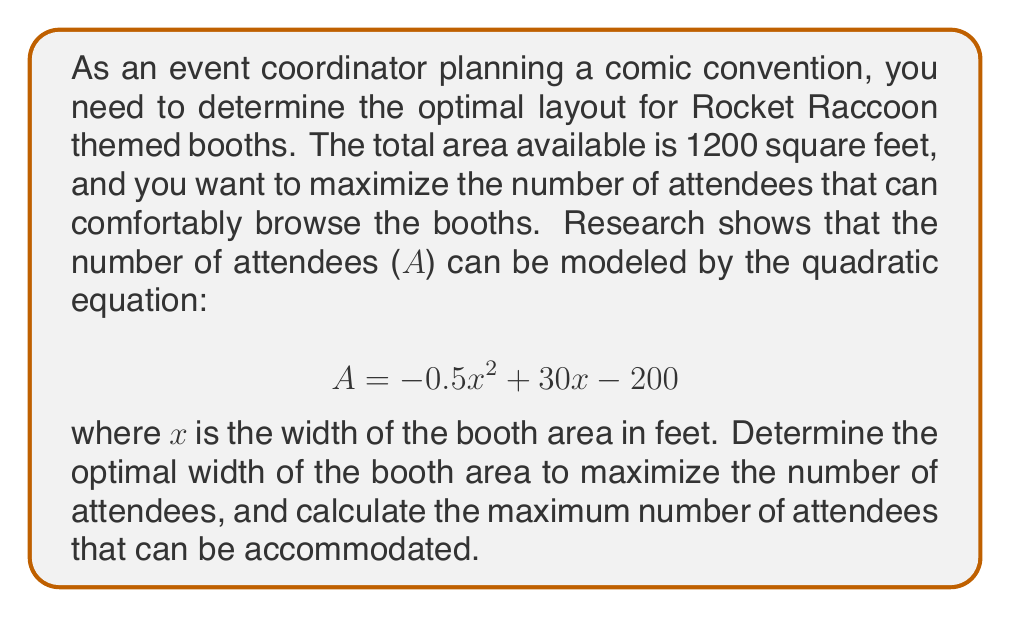Teach me how to tackle this problem. To solve this problem, we'll follow these steps:

1) First, we need to find the vertex of the parabola, which represents the maximum point. We can do this using the vertex formula: $x = -\frac{b}{2a}$

2) In this equation, $a = -0.5$ and $b = 30$. Let's substitute these values:

   $$x = -\frac{30}{2(-0.5)} = -\frac{30}{-1} = 30$$

3) This means the optimal width of the booth area is 30 feet.

4) To find the maximum number of attendees, we substitute x = 30 into the original equation:

   $$A = -0.5(30)^2 + 30(30) - 200$$

5) Let's calculate this step by step:
   $$A = -0.5(900) + 900 - 200$$
   $$A = -450 + 900 - 200$$
   $$A = 450 - 200 = 250$$

6) Therefore, the maximum number of attendees that can be accommodated is 250.
Answer: Optimal width: 30 feet; Maximum attendees: 250 